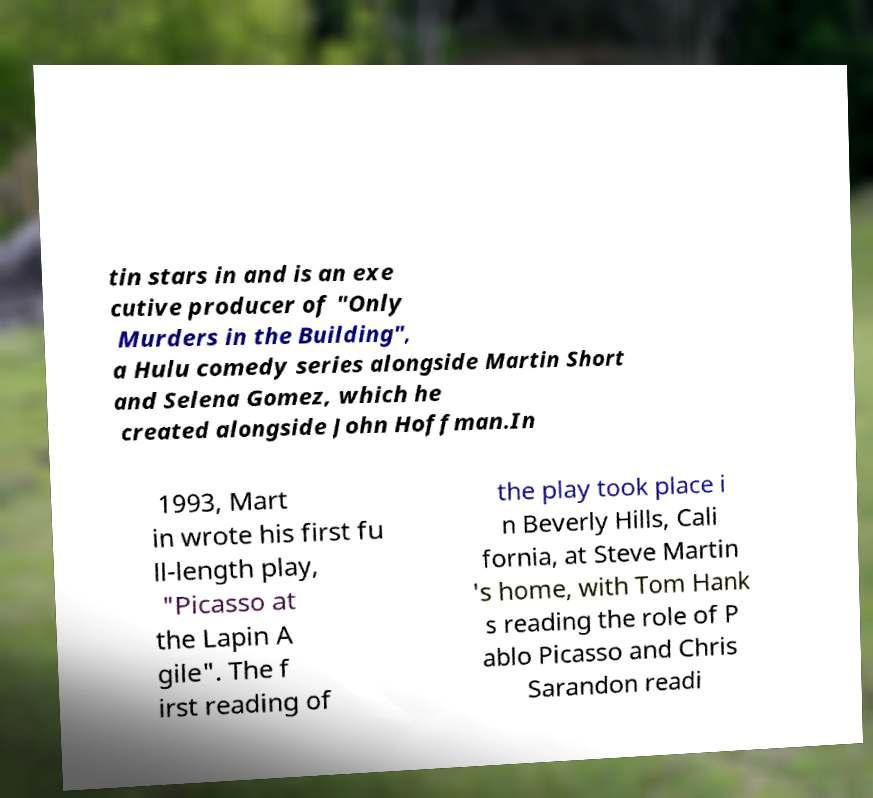Could you extract and type out the text from this image? tin stars in and is an exe cutive producer of "Only Murders in the Building", a Hulu comedy series alongside Martin Short and Selena Gomez, which he created alongside John Hoffman.In 1993, Mart in wrote his first fu ll-length play, "Picasso at the Lapin A gile". The f irst reading of the play took place i n Beverly Hills, Cali fornia, at Steve Martin 's home, with Tom Hank s reading the role of P ablo Picasso and Chris Sarandon readi 